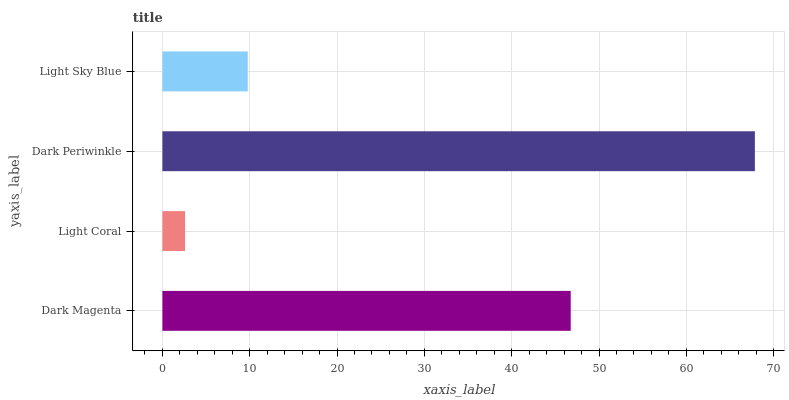Is Light Coral the minimum?
Answer yes or no. Yes. Is Dark Periwinkle the maximum?
Answer yes or no. Yes. Is Dark Periwinkle the minimum?
Answer yes or no. No. Is Light Coral the maximum?
Answer yes or no. No. Is Dark Periwinkle greater than Light Coral?
Answer yes or no. Yes. Is Light Coral less than Dark Periwinkle?
Answer yes or no. Yes. Is Light Coral greater than Dark Periwinkle?
Answer yes or no. No. Is Dark Periwinkle less than Light Coral?
Answer yes or no. No. Is Dark Magenta the high median?
Answer yes or no. Yes. Is Light Sky Blue the low median?
Answer yes or no. Yes. Is Light Coral the high median?
Answer yes or no. No. Is Dark Magenta the low median?
Answer yes or no. No. 